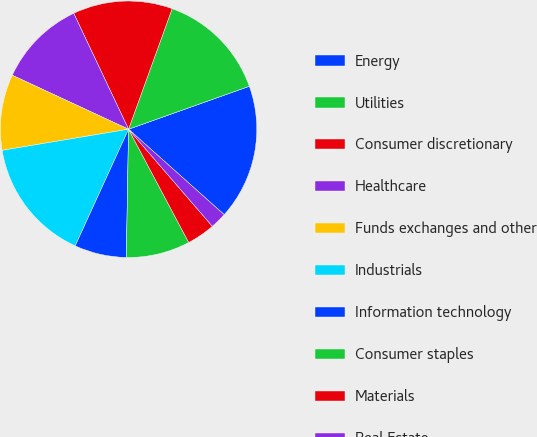Convert chart to OTSL. <chart><loc_0><loc_0><loc_500><loc_500><pie_chart><fcel>Energy<fcel>Utilities<fcel>Consumer discretionary<fcel>Healthcare<fcel>Funds exchanges and other<fcel>Industrials<fcel>Information technology<fcel>Consumer staples<fcel>Materials<fcel>Real Estate<nl><fcel>17.04%<fcel>14.04%<fcel>12.55%<fcel>11.05%<fcel>9.55%<fcel>15.54%<fcel>6.55%<fcel>8.05%<fcel>3.56%<fcel>2.06%<nl></chart> 